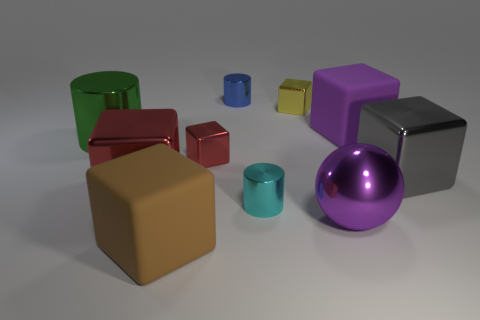The thing that is the same color as the metallic sphere is what size?
Make the answer very short. Large. There is a cylinder that is in front of the big green cylinder; what is it made of?
Make the answer very short. Metal. Do the small shiny object behind the small yellow object and the big purple object that is behind the purple metallic object have the same shape?
Give a very brief answer. No. What material is the large cube that is the same color as the metal ball?
Make the answer very short. Rubber. Are any brown objects visible?
Ensure brevity in your answer.  Yes. There is a small cyan object that is the same shape as the green thing; what material is it?
Ensure brevity in your answer.  Metal. There is a brown block; are there any yellow things in front of it?
Give a very brief answer. No. Are the purple block behind the tiny red metal object and the green cylinder made of the same material?
Ensure brevity in your answer.  No. Is there a tiny metal cube of the same color as the big ball?
Your response must be concise. No. The gray object is what shape?
Give a very brief answer. Cube. 